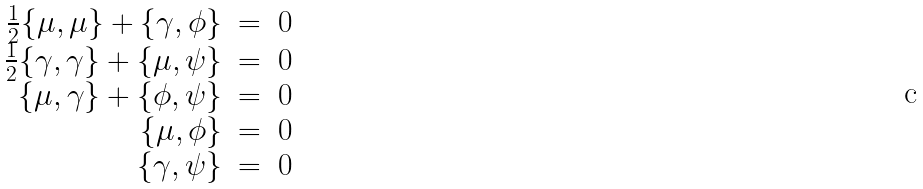Convert formula to latex. <formula><loc_0><loc_0><loc_500><loc_500>\begin{array} { r c l } \frac { 1 } { 2 } \{ \mu , \mu \} + \{ \gamma , \phi \} & = & 0 \\ \frac { 1 } { 2 } \{ \gamma , \gamma \} + \{ \mu , \psi \} & = & 0 \\ \{ \mu , \gamma \} + \{ \phi , \psi \} & = & 0 \\ \{ \mu , \phi \} & = & 0 \\ \{ \gamma , \psi \} & = & 0 \end{array}</formula> 